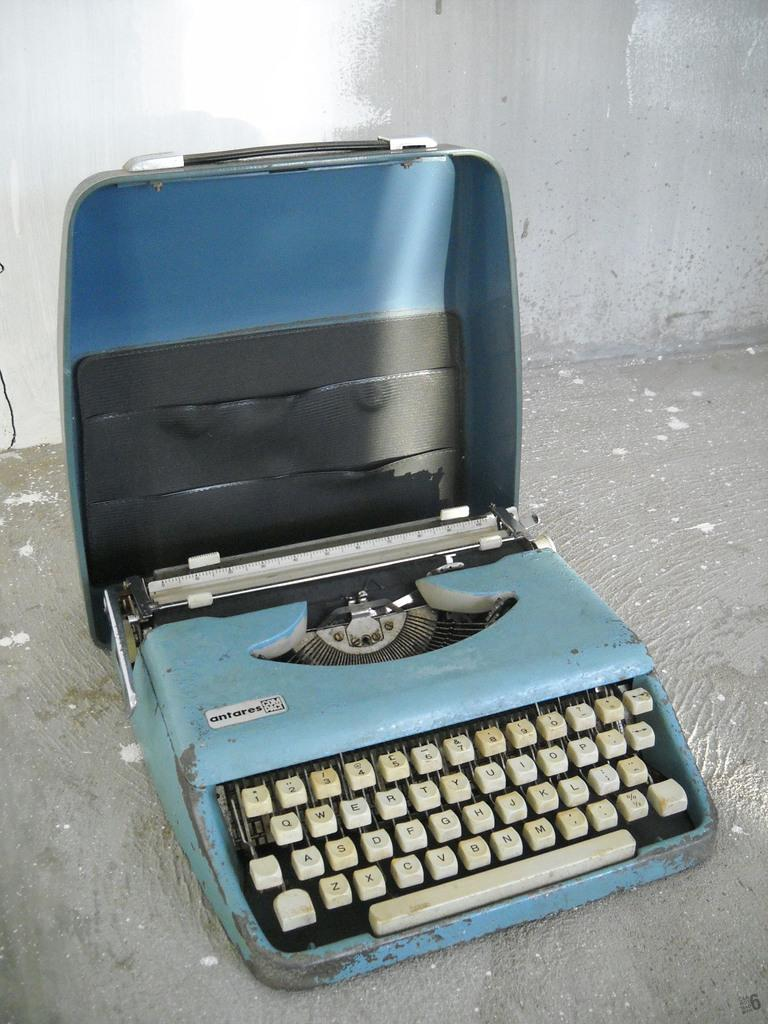What is the main object in the image? There is a portable typewriter in the image. What color is the typewriter? The typewriter is blue in color. What type of floor is visible in the image? There is a cement floor visible in the image. What can be seen in the background of the image? There is a wall in the background of the image. What colors are the wall in the background? The wall is in white and grey color. How many basketballs are on the typewriter in the image? There are no basketballs present in the image; the main object is a portable typewriter. 